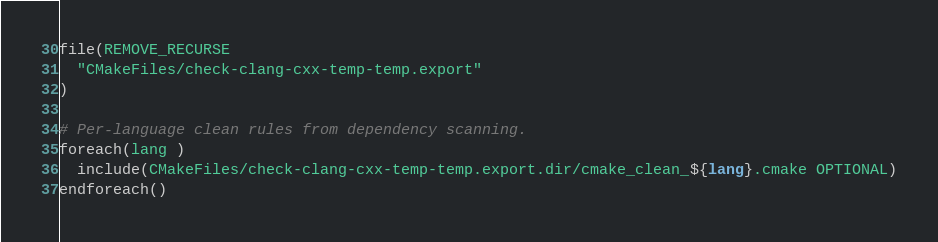Convert code to text. <code><loc_0><loc_0><loc_500><loc_500><_CMake_>file(REMOVE_RECURSE
  "CMakeFiles/check-clang-cxx-temp-temp.export"
)

# Per-language clean rules from dependency scanning.
foreach(lang )
  include(CMakeFiles/check-clang-cxx-temp-temp.export.dir/cmake_clean_${lang}.cmake OPTIONAL)
endforeach()
</code> 